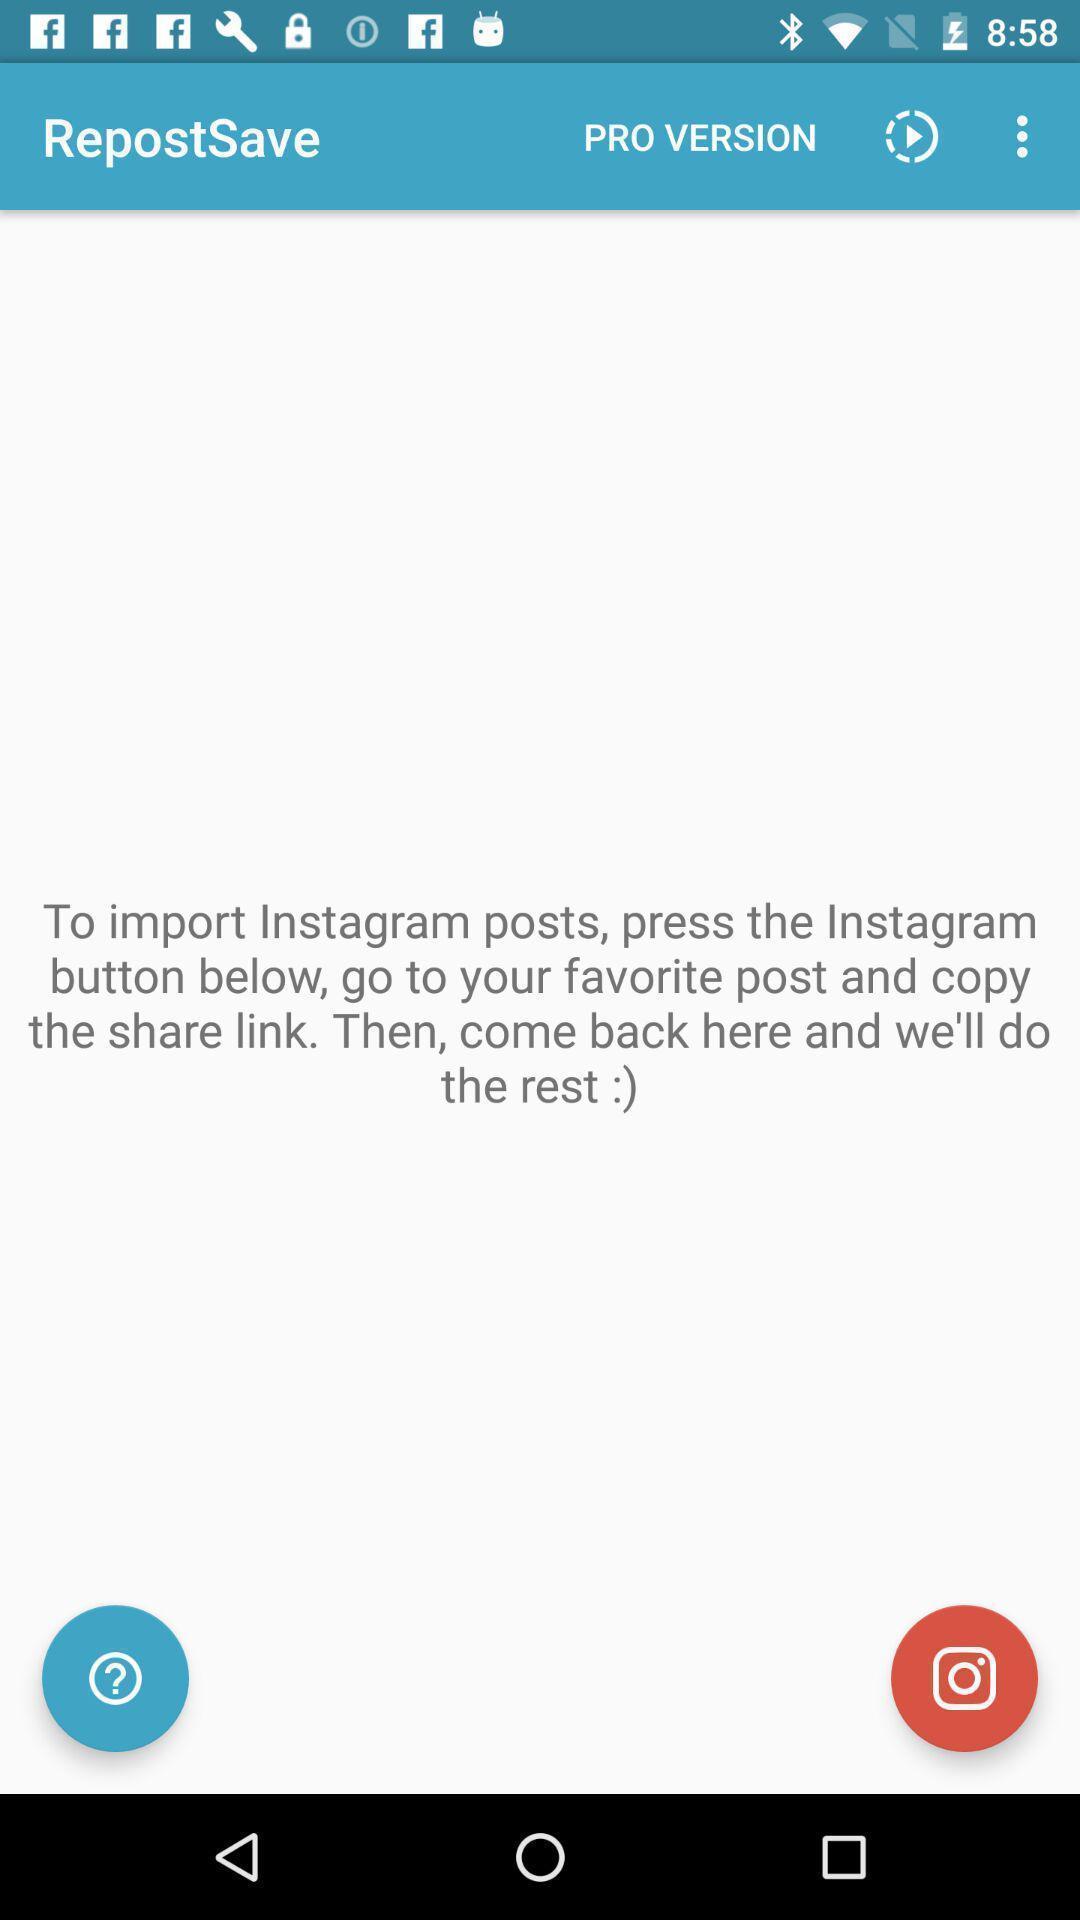Please provide a description for this image. Screen showing page. 